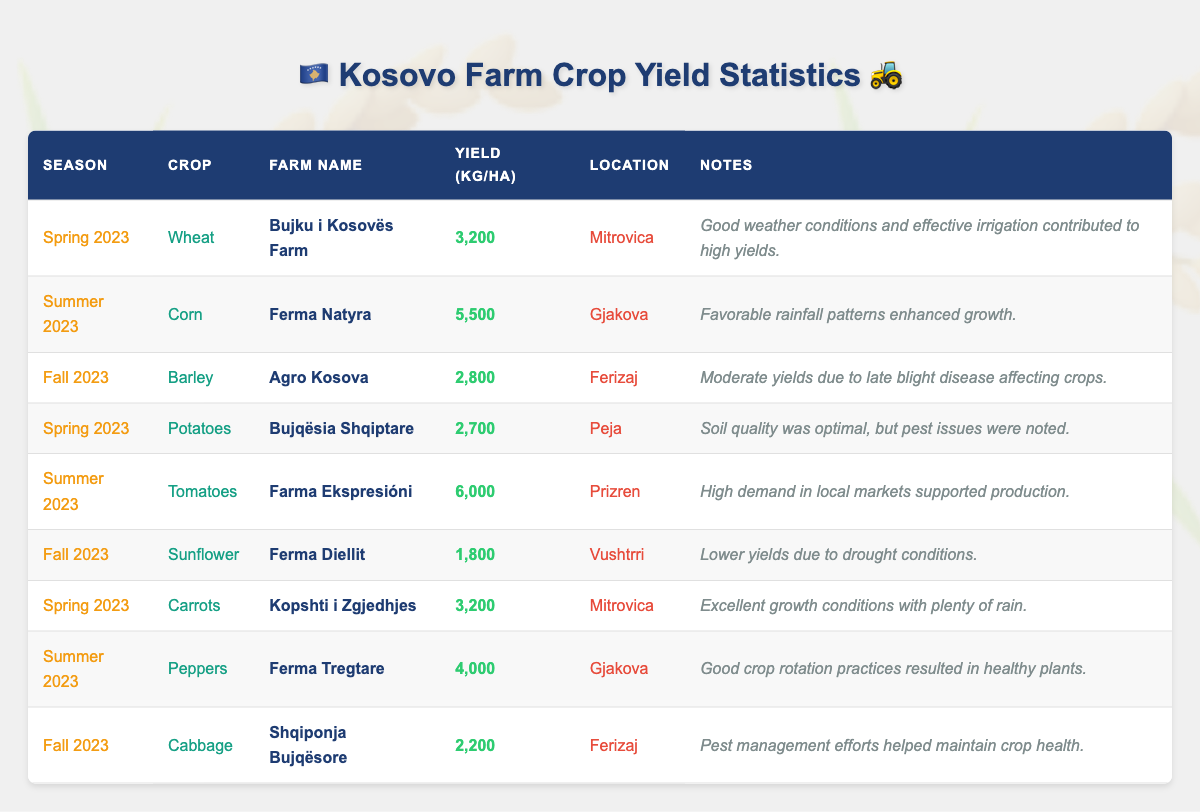What was the highest crop yield in Summer 2023? The table shows that the highest yield in Summer 2023 was from Tomatoes harvested at Farma Ekspresióni, with a yield of 6000 kg per hectare.
Answer: 6000 kg per hectare Which farm had the lowest yield in Fall 2023? According to the table, Ferma Diellit had the lowest yield in Fall 2023 for Sunflowers, with a yield of 1800 kg per hectare.
Answer: Ferma Diellit How many crops listed had a yield of over 3000 kg per hectare in Spring 2023? In Spring 2023, the crops Wheat (3200 kg/ha) and Carrots (3200 kg/ha) both had yields over 3000 kg per hectare, totaling 2 crops.
Answer: 2 What is the average crop yield for Summer 2023? The yields for Summer 2023 are 5500 kg/ha (Corn), 6000 kg/ha (Tomatoes), and 4000 kg/ha (Peppers). Summing them gives 5500 + 6000 + 4000 = 15500. Dividing by 3 (number of crops) gives an average of 15500 / 3 = 5166.67 kg/ha.
Answer: 5166.67 kg/ha Did Bujku i Kosovës Farm yield more in Spring 2023 than Bujqësia Shqiptare? Bujku i Kosovës Farm yielded 3200 kg/ha for Wheat, while Bujqësia Shqiptare yielded 2700 kg/ha for Potatoes. Thus, Bujku i Kosovës Farm had a higher yield.
Answer: Yes What is the total yield of Barley from Agro Kosova and Cabbage from Shqiponja Bujqësore in Fall 2023? The yield for Barley from Agro Kosova is 2800 kg/ha and for Cabbage from Shqiponja Bujqësore is 2200 kg/ha. Adding these yields gives 2800 + 2200 = 5000 kg/ha.
Answer: 5000 kg/ha How many crops were affected by pest issues according to the notes? The table indicates that Potatoes had pest issues at Bujqësia Shqiptare, and Cabbage management efforts helped maintain health, indicating pest issues indirectly could be present. Counting these gives 1 crop explicitly mentioned.
Answer: 1 Which crop had the highest yield in Mitrovica and what was that yield? The table shows that both Wheat (3200 kg/ha) and Carrots (3200 kg/ha) had the same yield in Mitrovica. Therefore, Mitrovica had the highest yield of 3200 kg/ha from those crops.
Answer: 3200 kg/ha What is the yield difference between Tomatoes and Corn in Summer 2023? Tomatoes had a yield of 6000 kg/ha and Corn had a yield of 5500 kg/ha in Summer 2023. The difference is calculated as 6000 - 5500 = 500 kg/ha.
Answer: 500 kg/ha Did any farms have a yield of Sunflower that exceeded 2000 kg per hectare? Ferma Diellit had a yield of 1800 kg/ha for Sunflowers, which is below 2000 kg/ha. Therefore, no farms exceeded this yield.
Answer: No 